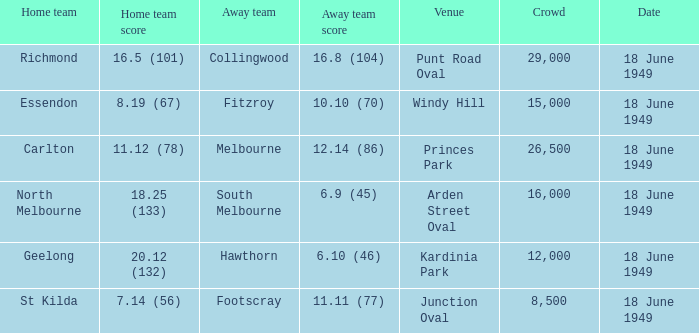What is the away team score when home team score is 20.12 (132)? 6.10 (46). 